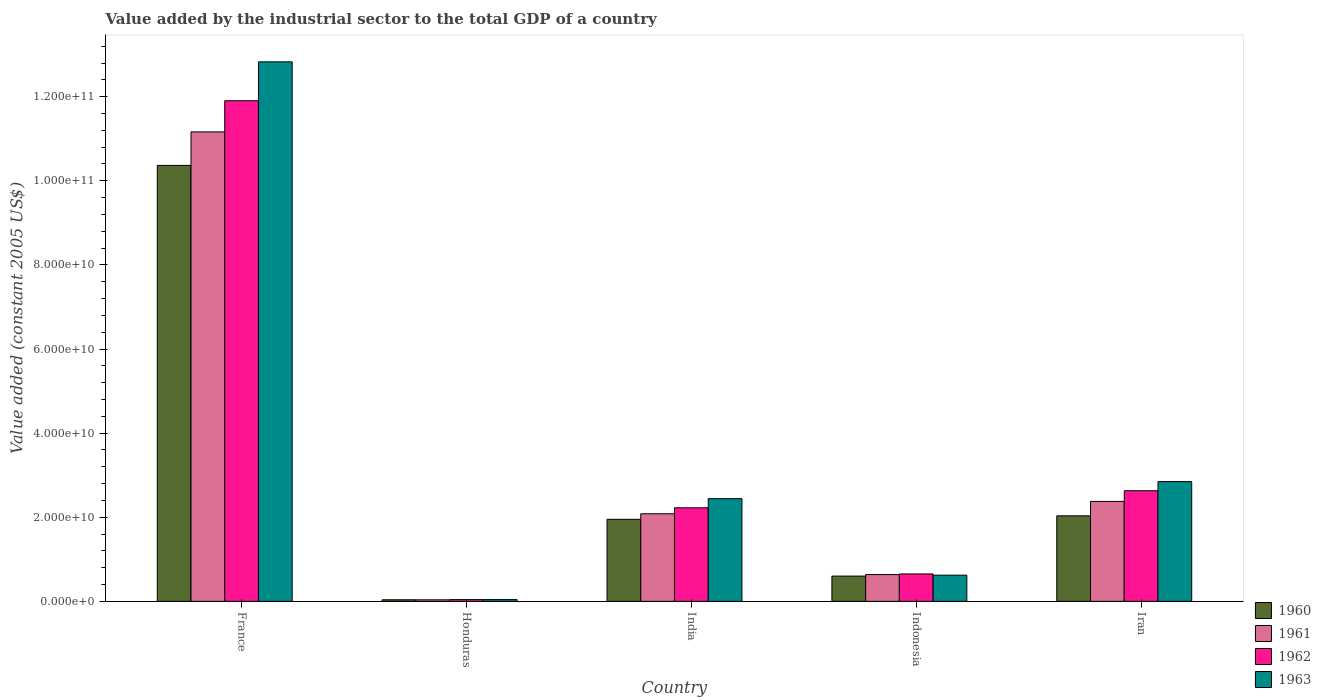How many different coloured bars are there?
Your answer should be compact. 4. Are the number of bars on each tick of the X-axis equal?
Offer a terse response. Yes. How many bars are there on the 4th tick from the right?
Offer a very short reply. 4. What is the label of the 2nd group of bars from the left?
Offer a very short reply. Honduras. What is the value added by the industrial sector in 1962 in France?
Give a very brief answer. 1.19e+11. Across all countries, what is the maximum value added by the industrial sector in 1962?
Ensure brevity in your answer.  1.19e+11. Across all countries, what is the minimum value added by the industrial sector in 1963?
Offer a terse response. 4.23e+08. In which country was the value added by the industrial sector in 1962 minimum?
Offer a terse response. Honduras. What is the total value added by the industrial sector in 1962 in the graph?
Provide a succinct answer. 1.75e+11. What is the difference between the value added by the industrial sector in 1960 in India and that in Indonesia?
Provide a succinct answer. 1.35e+1. What is the difference between the value added by the industrial sector in 1963 in Iran and the value added by the industrial sector in 1961 in Indonesia?
Make the answer very short. 2.21e+1. What is the average value added by the industrial sector in 1960 per country?
Keep it short and to the point. 3.00e+1. What is the difference between the value added by the industrial sector of/in 1960 and value added by the industrial sector of/in 1962 in France?
Provide a succinct answer. -1.54e+1. In how many countries, is the value added by the industrial sector in 1963 greater than 96000000000 US$?
Your response must be concise. 1. What is the ratio of the value added by the industrial sector in 1963 in India to that in Iran?
Your answer should be very brief. 0.86. Is the value added by the industrial sector in 1963 in India less than that in Iran?
Your answer should be compact. Yes. Is the difference between the value added by the industrial sector in 1960 in Indonesia and Iran greater than the difference between the value added by the industrial sector in 1962 in Indonesia and Iran?
Keep it short and to the point. Yes. What is the difference between the highest and the second highest value added by the industrial sector in 1963?
Offer a terse response. -1.04e+11. What is the difference between the highest and the lowest value added by the industrial sector in 1960?
Your answer should be compact. 1.03e+11. In how many countries, is the value added by the industrial sector in 1960 greater than the average value added by the industrial sector in 1960 taken over all countries?
Provide a short and direct response. 1. Is it the case that in every country, the sum of the value added by the industrial sector in 1961 and value added by the industrial sector in 1962 is greater than the sum of value added by the industrial sector in 1960 and value added by the industrial sector in 1963?
Keep it short and to the point. No. What does the 4th bar from the left in Honduras represents?
Offer a very short reply. 1963. What does the 4th bar from the right in Indonesia represents?
Ensure brevity in your answer.  1960. Is it the case that in every country, the sum of the value added by the industrial sector in 1963 and value added by the industrial sector in 1962 is greater than the value added by the industrial sector in 1960?
Ensure brevity in your answer.  Yes. Are all the bars in the graph horizontal?
Offer a terse response. No. Are the values on the major ticks of Y-axis written in scientific E-notation?
Ensure brevity in your answer.  Yes. Where does the legend appear in the graph?
Provide a short and direct response. Bottom right. What is the title of the graph?
Make the answer very short. Value added by the industrial sector to the total GDP of a country. What is the label or title of the Y-axis?
Your answer should be very brief. Value added (constant 2005 US$). What is the Value added (constant 2005 US$) in 1960 in France?
Provide a short and direct response. 1.04e+11. What is the Value added (constant 2005 US$) of 1961 in France?
Make the answer very short. 1.12e+11. What is the Value added (constant 2005 US$) in 1962 in France?
Provide a short and direct response. 1.19e+11. What is the Value added (constant 2005 US$) in 1963 in France?
Make the answer very short. 1.28e+11. What is the Value added (constant 2005 US$) in 1960 in Honduras?
Offer a very short reply. 3.75e+08. What is the Value added (constant 2005 US$) in 1961 in Honduras?
Give a very brief answer. 3.66e+08. What is the Value added (constant 2005 US$) in 1962 in Honduras?
Offer a terse response. 4.16e+08. What is the Value added (constant 2005 US$) of 1963 in Honduras?
Give a very brief answer. 4.23e+08. What is the Value added (constant 2005 US$) in 1960 in India?
Your response must be concise. 1.95e+1. What is the Value added (constant 2005 US$) of 1961 in India?
Your answer should be very brief. 2.08e+1. What is the Value added (constant 2005 US$) in 1962 in India?
Give a very brief answer. 2.22e+1. What is the Value added (constant 2005 US$) of 1963 in India?
Your answer should be compact. 2.44e+1. What is the Value added (constant 2005 US$) in 1960 in Indonesia?
Your answer should be compact. 6.01e+09. What is the Value added (constant 2005 US$) in 1961 in Indonesia?
Your answer should be compact. 6.37e+09. What is the Value added (constant 2005 US$) in 1962 in Indonesia?
Provide a short and direct response. 6.52e+09. What is the Value added (constant 2005 US$) of 1963 in Indonesia?
Keep it short and to the point. 6.23e+09. What is the Value added (constant 2005 US$) in 1960 in Iran?
Provide a succinct answer. 2.03e+1. What is the Value added (constant 2005 US$) of 1961 in Iran?
Make the answer very short. 2.38e+1. What is the Value added (constant 2005 US$) of 1962 in Iran?
Ensure brevity in your answer.  2.63e+1. What is the Value added (constant 2005 US$) in 1963 in Iran?
Keep it short and to the point. 2.85e+1. Across all countries, what is the maximum Value added (constant 2005 US$) of 1960?
Offer a very short reply. 1.04e+11. Across all countries, what is the maximum Value added (constant 2005 US$) of 1961?
Offer a very short reply. 1.12e+11. Across all countries, what is the maximum Value added (constant 2005 US$) in 1962?
Provide a succinct answer. 1.19e+11. Across all countries, what is the maximum Value added (constant 2005 US$) of 1963?
Make the answer very short. 1.28e+11. Across all countries, what is the minimum Value added (constant 2005 US$) of 1960?
Keep it short and to the point. 3.75e+08. Across all countries, what is the minimum Value added (constant 2005 US$) of 1961?
Ensure brevity in your answer.  3.66e+08. Across all countries, what is the minimum Value added (constant 2005 US$) of 1962?
Offer a terse response. 4.16e+08. Across all countries, what is the minimum Value added (constant 2005 US$) in 1963?
Your response must be concise. 4.23e+08. What is the total Value added (constant 2005 US$) of 1960 in the graph?
Give a very brief answer. 1.50e+11. What is the total Value added (constant 2005 US$) in 1961 in the graph?
Your answer should be very brief. 1.63e+11. What is the total Value added (constant 2005 US$) of 1962 in the graph?
Give a very brief answer. 1.75e+11. What is the total Value added (constant 2005 US$) of 1963 in the graph?
Provide a short and direct response. 1.88e+11. What is the difference between the Value added (constant 2005 US$) of 1960 in France and that in Honduras?
Provide a short and direct response. 1.03e+11. What is the difference between the Value added (constant 2005 US$) of 1961 in France and that in Honduras?
Ensure brevity in your answer.  1.11e+11. What is the difference between the Value added (constant 2005 US$) of 1962 in France and that in Honduras?
Your answer should be compact. 1.19e+11. What is the difference between the Value added (constant 2005 US$) in 1963 in France and that in Honduras?
Keep it short and to the point. 1.28e+11. What is the difference between the Value added (constant 2005 US$) in 1960 in France and that in India?
Give a very brief answer. 8.42e+1. What is the difference between the Value added (constant 2005 US$) in 1961 in France and that in India?
Your answer should be very brief. 9.08e+1. What is the difference between the Value added (constant 2005 US$) in 1962 in France and that in India?
Your answer should be compact. 9.68e+1. What is the difference between the Value added (constant 2005 US$) of 1963 in France and that in India?
Your answer should be compact. 1.04e+11. What is the difference between the Value added (constant 2005 US$) of 1960 in France and that in Indonesia?
Offer a terse response. 9.77e+1. What is the difference between the Value added (constant 2005 US$) of 1961 in France and that in Indonesia?
Ensure brevity in your answer.  1.05e+11. What is the difference between the Value added (constant 2005 US$) in 1962 in France and that in Indonesia?
Provide a succinct answer. 1.13e+11. What is the difference between the Value added (constant 2005 US$) in 1963 in France and that in Indonesia?
Your answer should be very brief. 1.22e+11. What is the difference between the Value added (constant 2005 US$) of 1960 in France and that in Iran?
Ensure brevity in your answer.  8.33e+1. What is the difference between the Value added (constant 2005 US$) of 1961 in France and that in Iran?
Make the answer very short. 8.79e+1. What is the difference between the Value added (constant 2005 US$) in 1962 in France and that in Iran?
Make the answer very short. 9.27e+1. What is the difference between the Value added (constant 2005 US$) in 1963 in France and that in Iran?
Ensure brevity in your answer.  9.98e+1. What is the difference between the Value added (constant 2005 US$) of 1960 in Honduras and that in India?
Provide a short and direct response. -1.91e+1. What is the difference between the Value added (constant 2005 US$) of 1961 in Honduras and that in India?
Ensure brevity in your answer.  -2.05e+1. What is the difference between the Value added (constant 2005 US$) in 1962 in Honduras and that in India?
Offer a terse response. -2.18e+1. What is the difference between the Value added (constant 2005 US$) in 1963 in Honduras and that in India?
Provide a succinct answer. -2.40e+1. What is the difference between the Value added (constant 2005 US$) of 1960 in Honduras and that in Indonesia?
Keep it short and to the point. -5.63e+09. What is the difference between the Value added (constant 2005 US$) of 1961 in Honduras and that in Indonesia?
Give a very brief answer. -6.00e+09. What is the difference between the Value added (constant 2005 US$) of 1962 in Honduras and that in Indonesia?
Offer a terse response. -6.10e+09. What is the difference between the Value added (constant 2005 US$) of 1963 in Honduras and that in Indonesia?
Make the answer very short. -5.81e+09. What is the difference between the Value added (constant 2005 US$) in 1960 in Honduras and that in Iran?
Your answer should be compact. -2.00e+1. What is the difference between the Value added (constant 2005 US$) in 1961 in Honduras and that in Iran?
Offer a very short reply. -2.34e+1. What is the difference between the Value added (constant 2005 US$) in 1962 in Honduras and that in Iran?
Give a very brief answer. -2.59e+1. What is the difference between the Value added (constant 2005 US$) of 1963 in Honduras and that in Iran?
Provide a short and direct response. -2.81e+1. What is the difference between the Value added (constant 2005 US$) of 1960 in India and that in Indonesia?
Provide a succinct answer. 1.35e+1. What is the difference between the Value added (constant 2005 US$) of 1961 in India and that in Indonesia?
Your answer should be very brief. 1.45e+1. What is the difference between the Value added (constant 2005 US$) in 1962 in India and that in Indonesia?
Ensure brevity in your answer.  1.57e+1. What is the difference between the Value added (constant 2005 US$) of 1963 in India and that in Indonesia?
Your response must be concise. 1.82e+1. What is the difference between the Value added (constant 2005 US$) of 1960 in India and that in Iran?
Offer a terse response. -8.36e+08. What is the difference between the Value added (constant 2005 US$) of 1961 in India and that in Iran?
Your answer should be compact. -2.94e+09. What is the difference between the Value added (constant 2005 US$) in 1962 in India and that in Iran?
Make the answer very short. -4.06e+09. What is the difference between the Value added (constant 2005 US$) in 1963 in India and that in Iran?
Provide a succinct answer. -4.05e+09. What is the difference between the Value added (constant 2005 US$) of 1960 in Indonesia and that in Iran?
Keep it short and to the point. -1.43e+1. What is the difference between the Value added (constant 2005 US$) in 1961 in Indonesia and that in Iran?
Ensure brevity in your answer.  -1.74e+1. What is the difference between the Value added (constant 2005 US$) in 1962 in Indonesia and that in Iran?
Provide a succinct answer. -1.98e+1. What is the difference between the Value added (constant 2005 US$) of 1963 in Indonesia and that in Iran?
Offer a very short reply. -2.22e+1. What is the difference between the Value added (constant 2005 US$) of 1960 in France and the Value added (constant 2005 US$) of 1961 in Honduras?
Offer a terse response. 1.03e+11. What is the difference between the Value added (constant 2005 US$) in 1960 in France and the Value added (constant 2005 US$) in 1962 in Honduras?
Give a very brief answer. 1.03e+11. What is the difference between the Value added (constant 2005 US$) in 1960 in France and the Value added (constant 2005 US$) in 1963 in Honduras?
Make the answer very short. 1.03e+11. What is the difference between the Value added (constant 2005 US$) in 1961 in France and the Value added (constant 2005 US$) in 1962 in Honduras?
Keep it short and to the point. 1.11e+11. What is the difference between the Value added (constant 2005 US$) of 1961 in France and the Value added (constant 2005 US$) of 1963 in Honduras?
Your answer should be very brief. 1.11e+11. What is the difference between the Value added (constant 2005 US$) in 1962 in France and the Value added (constant 2005 US$) in 1963 in Honduras?
Provide a short and direct response. 1.19e+11. What is the difference between the Value added (constant 2005 US$) of 1960 in France and the Value added (constant 2005 US$) of 1961 in India?
Make the answer very short. 8.28e+1. What is the difference between the Value added (constant 2005 US$) of 1960 in France and the Value added (constant 2005 US$) of 1962 in India?
Your response must be concise. 8.14e+1. What is the difference between the Value added (constant 2005 US$) in 1960 in France and the Value added (constant 2005 US$) in 1963 in India?
Provide a succinct answer. 7.92e+1. What is the difference between the Value added (constant 2005 US$) of 1961 in France and the Value added (constant 2005 US$) of 1962 in India?
Offer a terse response. 8.94e+1. What is the difference between the Value added (constant 2005 US$) in 1961 in France and the Value added (constant 2005 US$) in 1963 in India?
Keep it short and to the point. 8.72e+1. What is the difference between the Value added (constant 2005 US$) of 1962 in France and the Value added (constant 2005 US$) of 1963 in India?
Your answer should be compact. 9.46e+1. What is the difference between the Value added (constant 2005 US$) of 1960 in France and the Value added (constant 2005 US$) of 1961 in Indonesia?
Give a very brief answer. 9.73e+1. What is the difference between the Value added (constant 2005 US$) in 1960 in France and the Value added (constant 2005 US$) in 1962 in Indonesia?
Give a very brief answer. 9.71e+1. What is the difference between the Value added (constant 2005 US$) in 1960 in France and the Value added (constant 2005 US$) in 1963 in Indonesia?
Provide a succinct answer. 9.74e+1. What is the difference between the Value added (constant 2005 US$) in 1961 in France and the Value added (constant 2005 US$) in 1962 in Indonesia?
Make the answer very short. 1.05e+11. What is the difference between the Value added (constant 2005 US$) of 1961 in France and the Value added (constant 2005 US$) of 1963 in Indonesia?
Provide a succinct answer. 1.05e+11. What is the difference between the Value added (constant 2005 US$) of 1962 in France and the Value added (constant 2005 US$) of 1963 in Indonesia?
Ensure brevity in your answer.  1.13e+11. What is the difference between the Value added (constant 2005 US$) in 1960 in France and the Value added (constant 2005 US$) in 1961 in Iran?
Your answer should be very brief. 7.99e+1. What is the difference between the Value added (constant 2005 US$) of 1960 in France and the Value added (constant 2005 US$) of 1962 in Iran?
Your response must be concise. 7.74e+1. What is the difference between the Value added (constant 2005 US$) of 1960 in France and the Value added (constant 2005 US$) of 1963 in Iran?
Offer a very short reply. 7.52e+1. What is the difference between the Value added (constant 2005 US$) of 1961 in France and the Value added (constant 2005 US$) of 1962 in Iran?
Your response must be concise. 8.53e+1. What is the difference between the Value added (constant 2005 US$) of 1961 in France and the Value added (constant 2005 US$) of 1963 in Iran?
Offer a very short reply. 8.32e+1. What is the difference between the Value added (constant 2005 US$) in 1962 in France and the Value added (constant 2005 US$) in 1963 in Iran?
Your response must be concise. 9.06e+1. What is the difference between the Value added (constant 2005 US$) in 1960 in Honduras and the Value added (constant 2005 US$) in 1961 in India?
Offer a terse response. -2.05e+1. What is the difference between the Value added (constant 2005 US$) in 1960 in Honduras and the Value added (constant 2005 US$) in 1962 in India?
Provide a succinct answer. -2.19e+1. What is the difference between the Value added (constant 2005 US$) of 1960 in Honduras and the Value added (constant 2005 US$) of 1963 in India?
Ensure brevity in your answer.  -2.41e+1. What is the difference between the Value added (constant 2005 US$) in 1961 in Honduras and the Value added (constant 2005 US$) in 1962 in India?
Your answer should be very brief. -2.19e+1. What is the difference between the Value added (constant 2005 US$) of 1961 in Honduras and the Value added (constant 2005 US$) of 1963 in India?
Ensure brevity in your answer.  -2.41e+1. What is the difference between the Value added (constant 2005 US$) in 1962 in Honduras and the Value added (constant 2005 US$) in 1963 in India?
Give a very brief answer. -2.40e+1. What is the difference between the Value added (constant 2005 US$) of 1960 in Honduras and the Value added (constant 2005 US$) of 1961 in Indonesia?
Give a very brief answer. -5.99e+09. What is the difference between the Value added (constant 2005 US$) in 1960 in Honduras and the Value added (constant 2005 US$) in 1962 in Indonesia?
Offer a terse response. -6.14e+09. What is the difference between the Value added (constant 2005 US$) of 1960 in Honduras and the Value added (constant 2005 US$) of 1963 in Indonesia?
Keep it short and to the point. -5.85e+09. What is the difference between the Value added (constant 2005 US$) of 1961 in Honduras and the Value added (constant 2005 US$) of 1962 in Indonesia?
Keep it short and to the point. -6.15e+09. What is the difference between the Value added (constant 2005 US$) in 1961 in Honduras and the Value added (constant 2005 US$) in 1963 in Indonesia?
Your answer should be compact. -5.86e+09. What is the difference between the Value added (constant 2005 US$) of 1962 in Honduras and the Value added (constant 2005 US$) of 1963 in Indonesia?
Your response must be concise. -5.81e+09. What is the difference between the Value added (constant 2005 US$) of 1960 in Honduras and the Value added (constant 2005 US$) of 1961 in Iran?
Give a very brief answer. -2.34e+1. What is the difference between the Value added (constant 2005 US$) of 1960 in Honduras and the Value added (constant 2005 US$) of 1962 in Iran?
Ensure brevity in your answer.  -2.59e+1. What is the difference between the Value added (constant 2005 US$) in 1960 in Honduras and the Value added (constant 2005 US$) in 1963 in Iran?
Your answer should be compact. -2.81e+1. What is the difference between the Value added (constant 2005 US$) in 1961 in Honduras and the Value added (constant 2005 US$) in 1962 in Iran?
Make the answer very short. -2.59e+1. What is the difference between the Value added (constant 2005 US$) in 1961 in Honduras and the Value added (constant 2005 US$) in 1963 in Iran?
Offer a terse response. -2.81e+1. What is the difference between the Value added (constant 2005 US$) in 1962 in Honduras and the Value added (constant 2005 US$) in 1963 in Iran?
Make the answer very short. -2.81e+1. What is the difference between the Value added (constant 2005 US$) in 1960 in India and the Value added (constant 2005 US$) in 1961 in Indonesia?
Make the answer very short. 1.31e+1. What is the difference between the Value added (constant 2005 US$) of 1960 in India and the Value added (constant 2005 US$) of 1962 in Indonesia?
Your response must be concise. 1.30e+1. What is the difference between the Value added (constant 2005 US$) in 1960 in India and the Value added (constant 2005 US$) in 1963 in Indonesia?
Offer a very short reply. 1.33e+1. What is the difference between the Value added (constant 2005 US$) in 1961 in India and the Value added (constant 2005 US$) in 1962 in Indonesia?
Ensure brevity in your answer.  1.43e+1. What is the difference between the Value added (constant 2005 US$) of 1961 in India and the Value added (constant 2005 US$) of 1963 in Indonesia?
Your answer should be very brief. 1.46e+1. What is the difference between the Value added (constant 2005 US$) in 1962 in India and the Value added (constant 2005 US$) in 1963 in Indonesia?
Ensure brevity in your answer.  1.60e+1. What is the difference between the Value added (constant 2005 US$) of 1960 in India and the Value added (constant 2005 US$) of 1961 in Iran?
Make the answer very short. -4.27e+09. What is the difference between the Value added (constant 2005 US$) in 1960 in India and the Value added (constant 2005 US$) in 1962 in Iran?
Make the answer very short. -6.80e+09. What is the difference between the Value added (constant 2005 US$) in 1960 in India and the Value added (constant 2005 US$) in 1963 in Iran?
Provide a short and direct response. -8.97e+09. What is the difference between the Value added (constant 2005 US$) of 1961 in India and the Value added (constant 2005 US$) of 1962 in Iran?
Give a very brief answer. -5.48e+09. What is the difference between the Value added (constant 2005 US$) in 1961 in India and the Value added (constant 2005 US$) in 1963 in Iran?
Offer a terse response. -7.65e+09. What is the difference between the Value added (constant 2005 US$) of 1962 in India and the Value added (constant 2005 US$) of 1963 in Iran?
Keep it short and to the point. -6.23e+09. What is the difference between the Value added (constant 2005 US$) of 1960 in Indonesia and the Value added (constant 2005 US$) of 1961 in Iran?
Provide a succinct answer. -1.78e+1. What is the difference between the Value added (constant 2005 US$) of 1960 in Indonesia and the Value added (constant 2005 US$) of 1962 in Iran?
Offer a very short reply. -2.03e+1. What is the difference between the Value added (constant 2005 US$) of 1960 in Indonesia and the Value added (constant 2005 US$) of 1963 in Iran?
Ensure brevity in your answer.  -2.25e+1. What is the difference between the Value added (constant 2005 US$) in 1961 in Indonesia and the Value added (constant 2005 US$) in 1962 in Iran?
Offer a very short reply. -1.99e+1. What is the difference between the Value added (constant 2005 US$) in 1961 in Indonesia and the Value added (constant 2005 US$) in 1963 in Iran?
Make the answer very short. -2.21e+1. What is the difference between the Value added (constant 2005 US$) of 1962 in Indonesia and the Value added (constant 2005 US$) of 1963 in Iran?
Offer a very short reply. -2.20e+1. What is the average Value added (constant 2005 US$) in 1960 per country?
Your answer should be very brief. 3.00e+1. What is the average Value added (constant 2005 US$) of 1961 per country?
Keep it short and to the point. 3.26e+1. What is the average Value added (constant 2005 US$) in 1962 per country?
Provide a succinct answer. 3.49e+1. What is the average Value added (constant 2005 US$) in 1963 per country?
Provide a succinct answer. 3.76e+1. What is the difference between the Value added (constant 2005 US$) in 1960 and Value added (constant 2005 US$) in 1961 in France?
Make the answer very short. -7.97e+09. What is the difference between the Value added (constant 2005 US$) of 1960 and Value added (constant 2005 US$) of 1962 in France?
Keep it short and to the point. -1.54e+1. What is the difference between the Value added (constant 2005 US$) in 1960 and Value added (constant 2005 US$) in 1963 in France?
Keep it short and to the point. -2.46e+1. What is the difference between the Value added (constant 2005 US$) in 1961 and Value added (constant 2005 US$) in 1962 in France?
Your answer should be compact. -7.41e+09. What is the difference between the Value added (constant 2005 US$) of 1961 and Value added (constant 2005 US$) of 1963 in France?
Make the answer very short. -1.67e+1. What is the difference between the Value added (constant 2005 US$) of 1962 and Value added (constant 2005 US$) of 1963 in France?
Make the answer very short. -9.25e+09. What is the difference between the Value added (constant 2005 US$) of 1960 and Value added (constant 2005 US$) of 1961 in Honduras?
Ensure brevity in your answer.  9.37e+06. What is the difference between the Value added (constant 2005 US$) of 1960 and Value added (constant 2005 US$) of 1962 in Honduras?
Provide a succinct answer. -4.07e+07. What is the difference between the Value added (constant 2005 US$) in 1960 and Value added (constant 2005 US$) in 1963 in Honduras?
Your response must be concise. -4.79e+07. What is the difference between the Value added (constant 2005 US$) of 1961 and Value added (constant 2005 US$) of 1962 in Honduras?
Keep it short and to the point. -5.00e+07. What is the difference between the Value added (constant 2005 US$) of 1961 and Value added (constant 2005 US$) of 1963 in Honduras?
Your answer should be compact. -5.72e+07. What is the difference between the Value added (constant 2005 US$) of 1962 and Value added (constant 2005 US$) of 1963 in Honduras?
Provide a short and direct response. -7.19e+06. What is the difference between the Value added (constant 2005 US$) in 1960 and Value added (constant 2005 US$) in 1961 in India?
Ensure brevity in your answer.  -1.32e+09. What is the difference between the Value added (constant 2005 US$) in 1960 and Value added (constant 2005 US$) in 1962 in India?
Make the answer very short. -2.74e+09. What is the difference between the Value added (constant 2005 US$) of 1960 and Value added (constant 2005 US$) of 1963 in India?
Your answer should be very brief. -4.92e+09. What is the difference between the Value added (constant 2005 US$) of 1961 and Value added (constant 2005 US$) of 1962 in India?
Your answer should be very brief. -1.42e+09. What is the difference between the Value added (constant 2005 US$) in 1961 and Value added (constant 2005 US$) in 1963 in India?
Offer a terse response. -3.60e+09. What is the difference between the Value added (constant 2005 US$) in 1962 and Value added (constant 2005 US$) in 1963 in India?
Offer a terse response. -2.18e+09. What is the difference between the Value added (constant 2005 US$) in 1960 and Value added (constant 2005 US$) in 1961 in Indonesia?
Your answer should be compact. -3.60e+08. What is the difference between the Value added (constant 2005 US$) of 1960 and Value added (constant 2005 US$) of 1962 in Indonesia?
Your response must be concise. -5.10e+08. What is the difference between the Value added (constant 2005 US$) of 1960 and Value added (constant 2005 US$) of 1963 in Indonesia?
Your answer should be very brief. -2.22e+08. What is the difference between the Value added (constant 2005 US$) of 1961 and Value added (constant 2005 US$) of 1962 in Indonesia?
Offer a terse response. -1.50e+08. What is the difference between the Value added (constant 2005 US$) of 1961 and Value added (constant 2005 US$) of 1963 in Indonesia?
Ensure brevity in your answer.  1.38e+08. What is the difference between the Value added (constant 2005 US$) in 1962 and Value added (constant 2005 US$) in 1963 in Indonesia?
Offer a very short reply. 2.88e+08. What is the difference between the Value added (constant 2005 US$) in 1960 and Value added (constant 2005 US$) in 1961 in Iran?
Keep it short and to the point. -3.43e+09. What is the difference between the Value added (constant 2005 US$) in 1960 and Value added (constant 2005 US$) in 1962 in Iran?
Your response must be concise. -5.96e+09. What is the difference between the Value added (constant 2005 US$) in 1960 and Value added (constant 2005 US$) in 1963 in Iran?
Your response must be concise. -8.14e+09. What is the difference between the Value added (constant 2005 US$) of 1961 and Value added (constant 2005 US$) of 1962 in Iran?
Provide a short and direct response. -2.53e+09. What is the difference between the Value added (constant 2005 US$) in 1961 and Value added (constant 2005 US$) in 1963 in Iran?
Ensure brevity in your answer.  -4.71e+09. What is the difference between the Value added (constant 2005 US$) of 1962 and Value added (constant 2005 US$) of 1963 in Iran?
Provide a short and direct response. -2.17e+09. What is the ratio of the Value added (constant 2005 US$) of 1960 in France to that in Honduras?
Provide a succinct answer. 276.31. What is the ratio of the Value added (constant 2005 US$) in 1961 in France to that in Honduras?
Keep it short and to the point. 305.16. What is the ratio of the Value added (constant 2005 US$) in 1962 in France to that in Honduras?
Provide a succinct answer. 286.26. What is the ratio of the Value added (constant 2005 US$) in 1963 in France to that in Honduras?
Keep it short and to the point. 303.25. What is the ratio of the Value added (constant 2005 US$) in 1960 in France to that in India?
Give a very brief answer. 5.32. What is the ratio of the Value added (constant 2005 US$) of 1961 in France to that in India?
Your answer should be compact. 5.36. What is the ratio of the Value added (constant 2005 US$) of 1962 in France to that in India?
Keep it short and to the point. 5.35. What is the ratio of the Value added (constant 2005 US$) in 1963 in France to that in India?
Offer a terse response. 5.25. What is the ratio of the Value added (constant 2005 US$) in 1960 in France to that in Indonesia?
Offer a very short reply. 17.26. What is the ratio of the Value added (constant 2005 US$) in 1961 in France to that in Indonesia?
Your answer should be very brief. 17.53. What is the ratio of the Value added (constant 2005 US$) of 1962 in France to that in Indonesia?
Provide a succinct answer. 18.27. What is the ratio of the Value added (constant 2005 US$) of 1963 in France to that in Indonesia?
Offer a terse response. 20.59. What is the ratio of the Value added (constant 2005 US$) of 1960 in France to that in Iran?
Your answer should be compact. 5.1. What is the ratio of the Value added (constant 2005 US$) in 1961 in France to that in Iran?
Provide a short and direct response. 4.7. What is the ratio of the Value added (constant 2005 US$) in 1962 in France to that in Iran?
Ensure brevity in your answer.  4.53. What is the ratio of the Value added (constant 2005 US$) of 1963 in France to that in Iran?
Offer a very short reply. 4.51. What is the ratio of the Value added (constant 2005 US$) of 1960 in Honduras to that in India?
Offer a very short reply. 0.02. What is the ratio of the Value added (constant 2005 US$) of 1961 in Honduras to that in India?
Offer a terse response. 0.02. What is the ratio of the Value added (constant 2005 US$) of 1962 in Honduras to that in India?
Keep it short and to the point. 0.02. What is the ratio of the Value added (constant 2005 US$) in 1963 in Honduras to that in India?
Your response must be concise. 0.02. What is the ratio of the Value added (constant 2005 US$) of 1960 in Honduras to that in Indonesia?
Make the answer very short. 0.06. What is the ratio of the Value added (constant 2005 US$) in 1961 in Honduras to that in Indonesia?
Provide a short and direct response. 0.06. What is the ratio of the Value added (constant 2005 US$) in 1962 in Honduras to that in Indonesia?
Provide a short and direct response. 0.06. What is the ratio of the Value added (constant 2005 US$) of 1963 in Honduras to that in Indonesia?
Your response must be concise. 0.07. What is the ratio of the Value added (constant 2005 US$) of 1960 in Honduras to that in Iran?
Make the answer very short. 0.02. What is the ratio of the Value added (constant 2005 US$) of 1961 in Honduras to that in Iran?
Provide a succinct answer. 0.02. What is the ratio of the Value added (constant 2005 US$) of 1962 in Honduras to that in Iran?
Provide a succinct answer. 0.02. What is the ratio of the Value added (constant 2005 US$) of 1963 in Honduras to that in Iran?
Offer a very short reply. 0.01. What is the ratio of the Value added (constant 2005 US$) of 1960 in India to that in Indonesia?
Your answer should be compact. 3.25. What is the ratio of the Value added (constant 2005 US$) of 1961 in India to that in Indonesia?
Give a very brief answer. 3.27. What is the ratio of the Value added (constant 2005 US$) in 1962 in India to that in Indonesia?
Offer a terse response. 3.41. What is the ratio of the Value added (constant 2005 US$) in 1963 in India to that in Indonesia?
Provide a short and direct response. 3.92. What is the ratio of the Value added (constant 2005 US$) of 1960 in India to that in Iran?
Give a very brief answer. 0.96. What is the ratio of the Value added (constant 2005 US$) of 1961 in India to that in Iran?
Offer a very short reply. 0.88. What is the ratio of the Value added (constant 2005 US$) in 1962 in India to that in Iran?
Your response must be concise. 0.85. What is the ratio of the Value added (constant 2005 US$) of 1963 in India to that in Iran?
Your answer should be very brief. 0.86. What is the ratio of the Value added (constant 2005 US$) in 1960 in Indonesia to that in Iran?
Ensure brevity in your answer.  0.3. What is the ratio of the Value added (constant 2005 US$) in 1961 in Indonesia to that in Iran?
Keep it short and to the point. 0.27. What is the ratio of the Value added (constant 2005 US$) in 1962 in Indonesia to that in Iran?
Offer a terse response. 0.25. What is the ratio of the Value added (constant 2005 US$) in 1963 in Indonesia to that in Iran?
Your answer should be very brief. 0.22. What is the difference between the highest and the second highest Value added (constant 2005 US$) of 1960?
Keep it short and to the point. 8.33e+1. What is the difference between the highest and the second highest Value added (constant 2005 US$) in 1961?
Your answer should be compact. 8.79e+1. What is the difference between the highest and the second highest Value added (constant 2005 US$) in 1962?
Make the answer very short. 9.27e+1. What is the difference between the highest and the second highest Value added (constant 2005 US$) in 1963?
Offer a very short reply. 9.98e+1. What is the difference between the highest and the lowest Value added (constant 2005 US$) of 1960?
Give a very brief answer. 1.03e+11. What is the difference between the highest and the lowest Value added (constant 2005 US$) of 1961?
Give a very brief answer. 1.11e+11. What is the difference between the highest and the lowest Value added (constant 2005 US$) in 1962?
Your response must be concise. 1.19e+11. What is the difference between the highest and the lowest Value added (constant 2005 US$) in 1963?
Your answer should be very brief. 1.28e+11. 